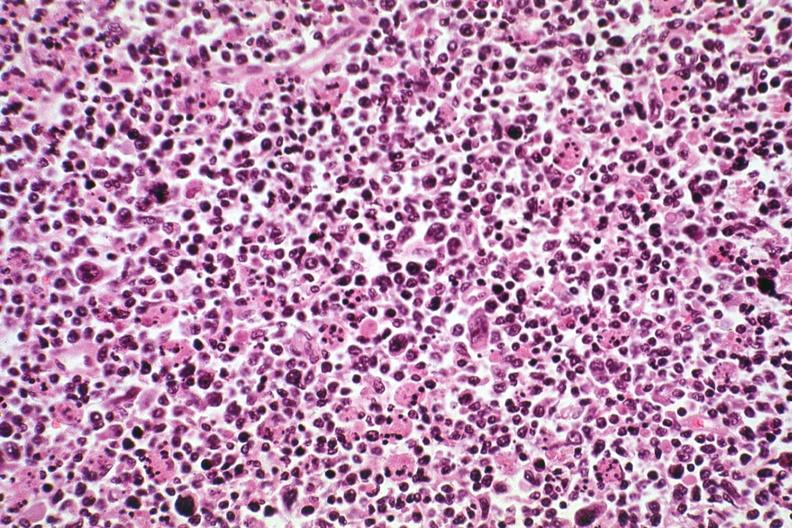s lymph node present?
Answer the question using a single word or phrase. Yes 